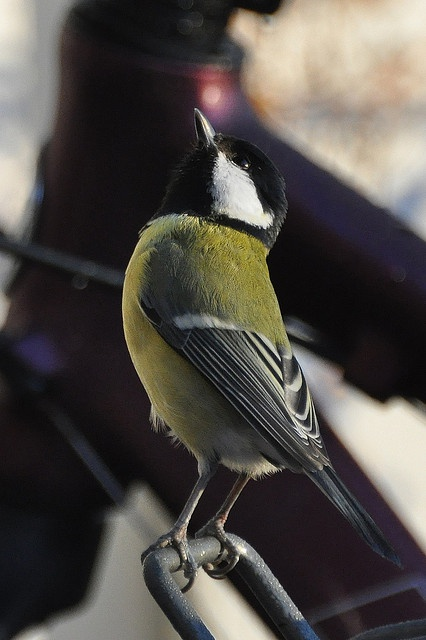Describe the objects in this image and their specific colors. I can see a bird in ivory, black, gray, darkgreen, and olive tones in this image. 